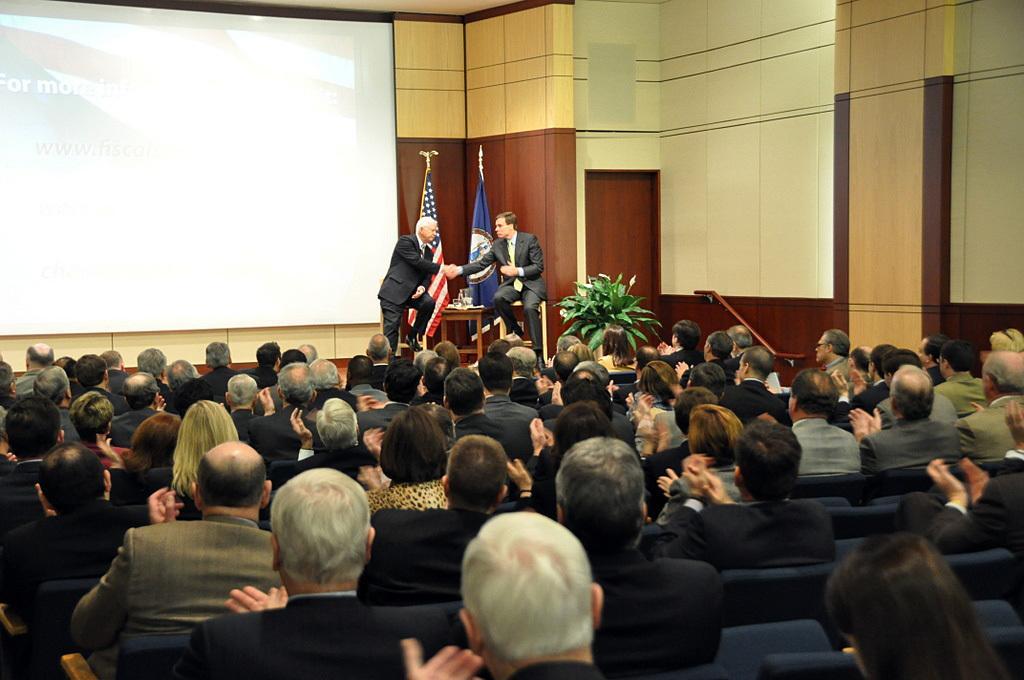How would you summarize this image in a sentence or two? In this picture we can see a group of people sitting on the chairs. In front of the people, there are flags, a houseplant, a table, a door and a projector screen and there are two men. On the right side of the image, there is a wall. 